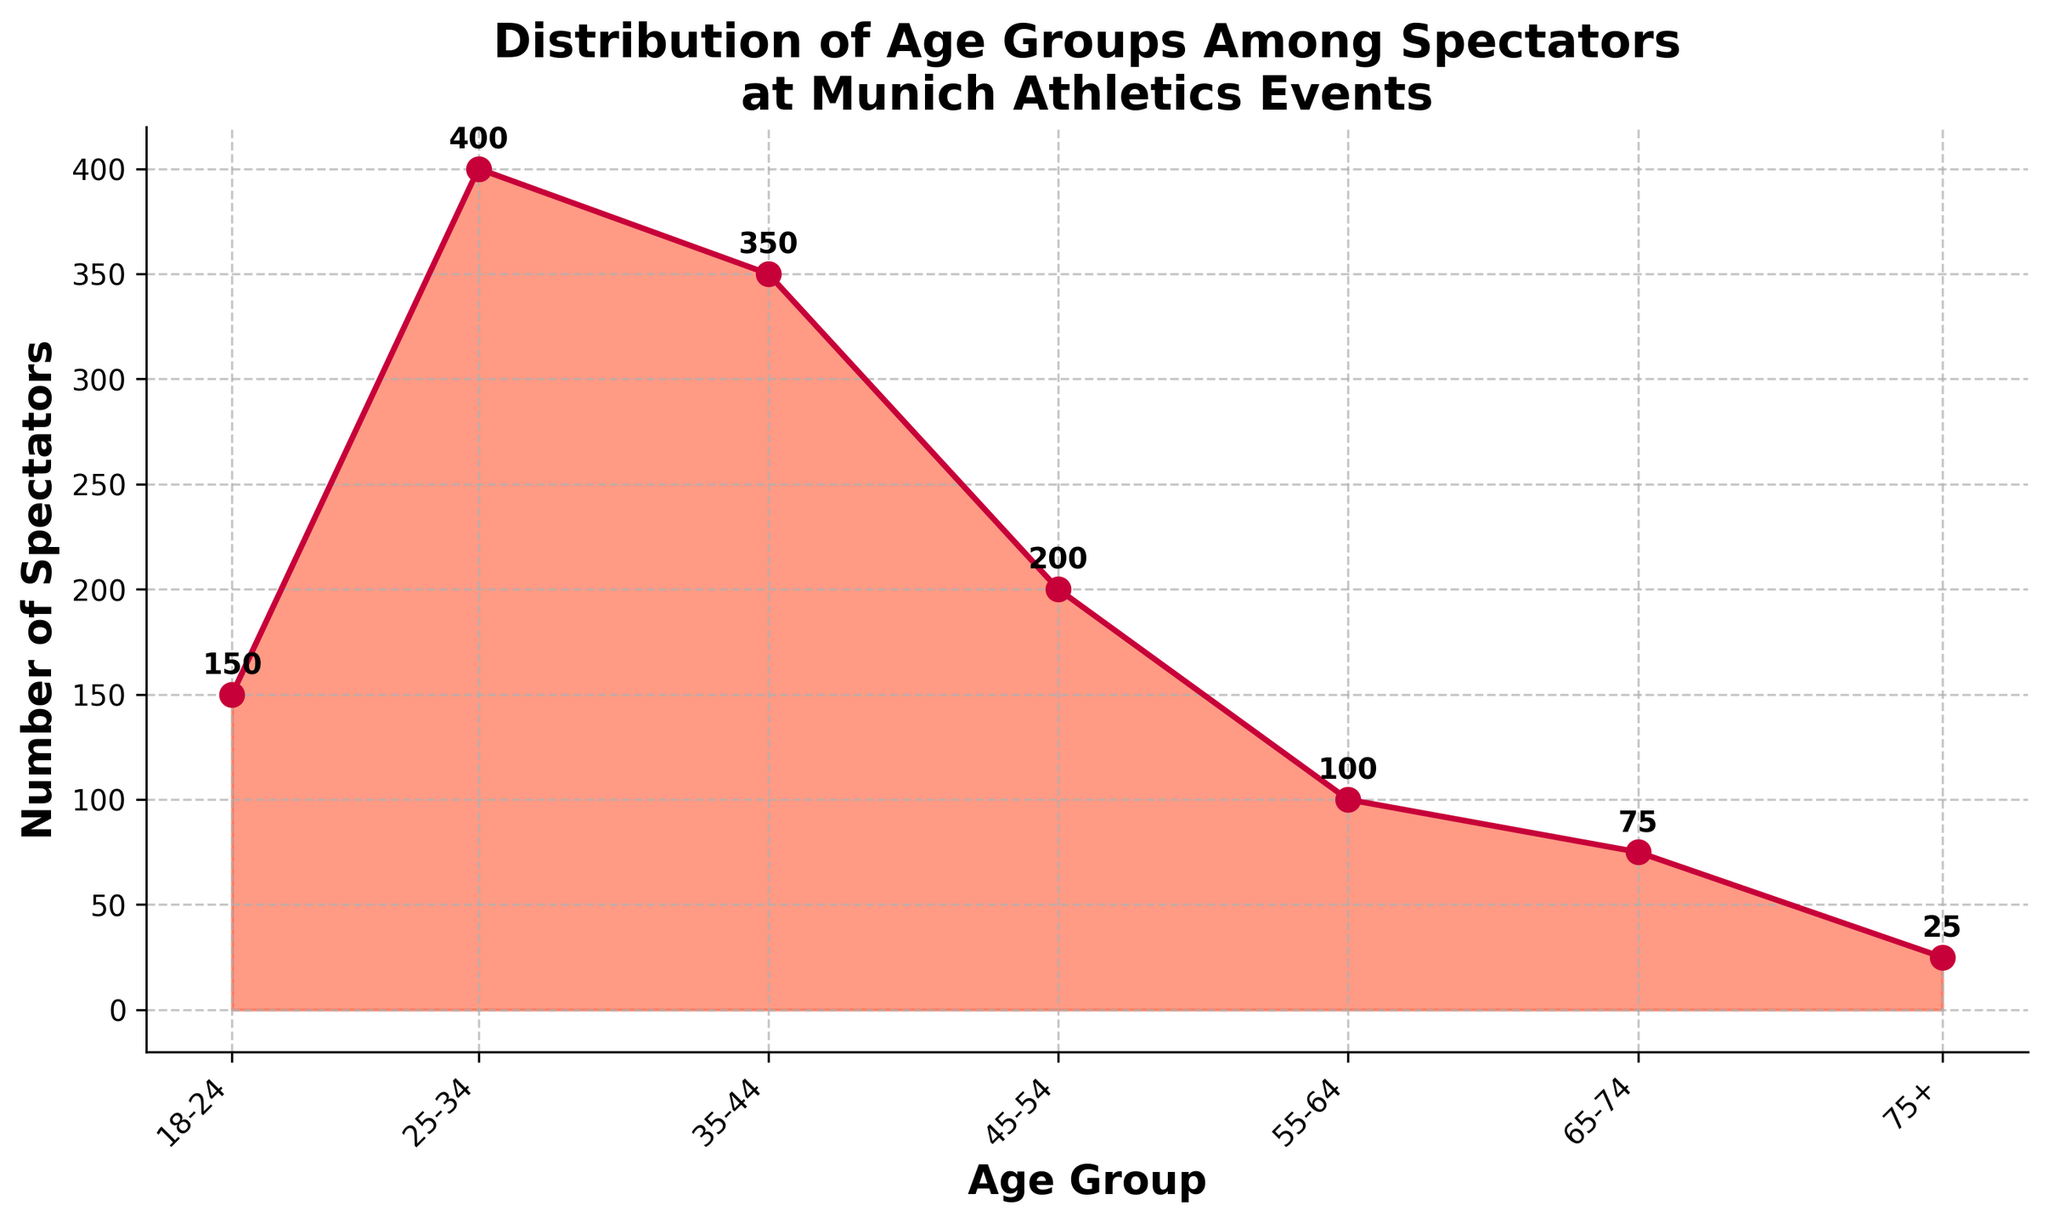what is the title of the plot? The title is usually placed at the top of the plot and summarizes the content. It reads "Distribution of Age Groups Among Spectators at Munich Athletics Events".
Answer: Distribution of Age Groups Among Spectators at Munich Athletics Events Which age group has the highest number of spectators? By looking at the peaks of the density plot, the highest peak corresponds to the age group 25-34 with a count of 400 spectators.
Answer: 25-34 How many spectators are in the 45-54 age group? The annotation on the plot for the age group 45-54 shows the count, which is 200 spectators.
Answer: 200 What is the total number of spectators counted in all age groups combined? Add the counts for all the age groups: 150 + 400 + 350 + 200 + 100 + 75 + 25 = 1300
Answer: 1300 Which age group has the least number of spectators? The lowest point in the density plot represents the age group 75+ with a count of 25 spectators.
Answer: 75+ Is the number of spectators in the age group 35-44 larger than the combined total of the 55-64 and 65-74 age groups? Compare the numbers: 35-44 has 350 spectators. 55-64 has 100 and 65-74 has 75, total is 100 + 75 = 175. Since 350 > 175, yes, it is larger.
Answer: Yes Compare the number of spectators in the 18-24 and 35-44 age groups. Which age group has more spectators? 18-24 has 150 spectators, and 35-44 has 350 spectators. Since 350 > 150, the 35-44 age group has more spectators.
Answer: 35-44 How does the number of spectators in the 25-34 age group compare to the 45-54 age group? 25-34 has 400 spectators, and 45-54 has 200 spectators. Since 400 > 200, the 25-34 age group has more spectators.
Answer: 25-34 Which age group has twice the number of spectators as the 65-74 age group? 65-74 has 75 spectators. Twice that number is 150. The 18-24 age group has 150 spectators.
Answer: 18-24 How many spectators are in the age groups below 35 years old? Add the counts for 18-24 and 25-34: 150 + 400 = 550
Answer: 550 